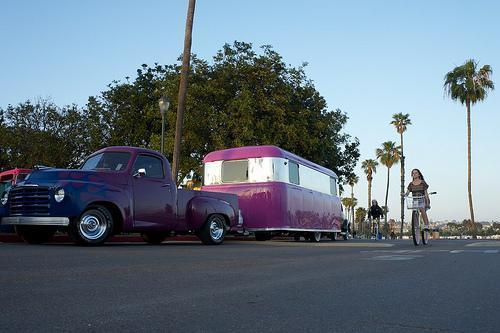How many people are in this picture?
Give a very brief answer. 2. 